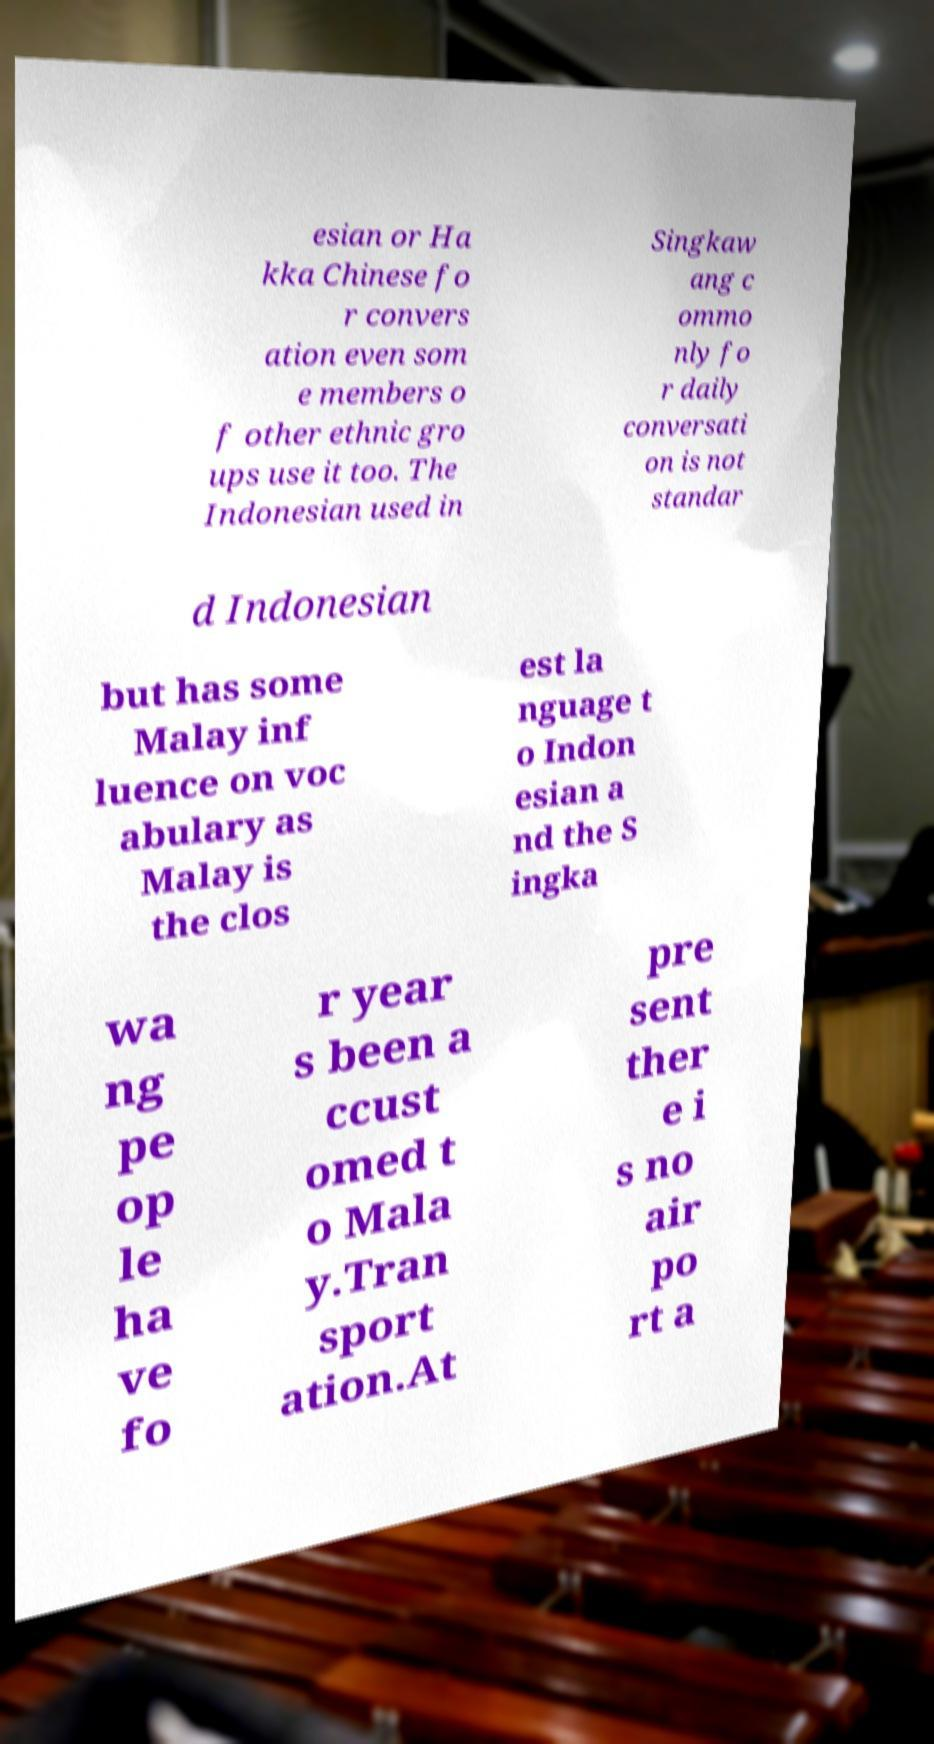For documentation purposes, I need the text within this image transcribed. Could you provide that? esian or Ha kka Chinese fo r convers ation even som e members o f other ethnic gro ups use it too. The Indonesian used in Singkaw ang c ommo nly fo r daily conversati on is not standar d Indonesian but has some Malay inf luence on voc abulary as Malay is the clos est la nguage t o Indon esian a nd the S ingka wa ng pe op le ha ve fo r year s been a ccust omed t o Mala y.Tran sport ation.At pre sent ther e i s no air po rt a 